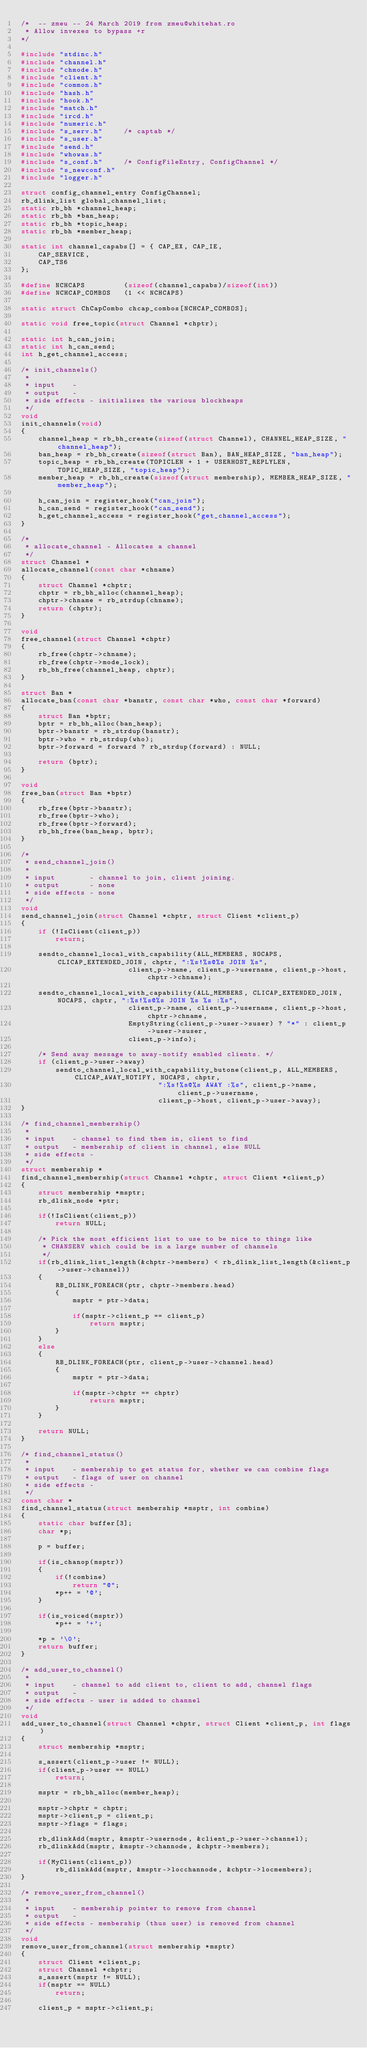<code> <loc_0><loc_0><loc_500><loc_500><_C_>/*  -- zmeu -- 24 March 2019 from zmeu@whitehat.ro
 * Allow invexes to bypass +r
*/

#include "stdinc.h"
#include "channel.h"
#include "chmode.h"
#include "client.h"
#include "common.h"
#include "hash.h"
#include "hook.h"
#include "match.h"
#include "ircd.h"
#include "numeric.h"
#include "s_serv.h"		/* captab */
#include "s_user.h"
#include "send.h"
#include "whowas.h"
#include "s_conf.h"		/* ConfigFileEntry, ConfigChannel */
#include "s_newconf.h"
#include "logger.h"

struct config_channel_entry ConfigChannel;
rb_dlink_list global_channel_list;
static rb_bh *channel_heap;
static rb_bh *ban_heap;
static rb_bh *topic_heap;
static rb_bh *member_heap;

static int channel_capabs[] = { CAP_EX, CAP_IE,
	CAP_SERVICE,
	CAP_TS6
};

#define NCHCAPS         (sizeof(channel_capabs)/sizeof(int))
#define NCHCAP_COMBOS   (1 << NCHCAPS)

static struct ChCapCombo chcap_combos[NCHCAP_COMBOS];

static void free_topic(struct Channel *chptr);

static int h_can_join;
static int h_can_send;
int h_get_channel_access;

/* init_channels()
 *
 * input	-
 * output	-
 * side effects - initialises the various blockheaps
 */
void
init_channels(void)
{
	channel_heap = rb_bh_create(sizeof(struct Channel), CHANNEL_HEAP_SIZE, "channel_heap");
	ban_heap = rb_bh_create(sizeof(struct Ban), BAN_HEAP_SIZE, "ban_heap");
	topic_heap = rb_bh_create(TOPICLEN + 1 + USERHOST_REPLYLEN, TOPIC_HEAP_SIZE, "topic_heap");
	member_heap = rb_bh_create(sizeof(struct membership), MEMBER_HEAP_SIZE, "member_heap");

	h_can_join = register_hook("can_join");
	h_can_send = register_hook("can_send");
	h_get_channel_access = register_hook("get_channel_access");
}

/*
 * allocate_channel - Allocates a channel
 */
struct Channel *
allocate_channel(const char *chname)
{
	struct Channel *chptr;
	chptr = rb_bh_alloc(channel_heap);
	chptr->chname = rb_strdup(chname);
	return (chptr);
}

void
free_channel(struct Channel *chptr)
{
	rb_free(chptr->chname);
	rb_free(chptr->mode_lock);
	rb_bh_free(channel_heap, chptr);
}

struct Ban *
allocate_ban(const char *banstr, const char *who, const char *forward)
{
	struct Ban *bptr;
	bptr = rb_bh_alloc(ban_heap);
	bptr->banstr = rb_strdup(banstr);
	bptr->who = rb_strdup(who);
	bptr->forward = forward ? rb_strdup(forward) : NULL;

	return (bptr);
}

void
free_ban(struct Ban *bptr)
{
	rb_free(bptr->banstr);
	rb_free(bptr->who);
	rb_free(bptr->forward);
	rb_bh_free(ban_heap, bptr);
}

/*
 * send_channel_join()
 *
 * input        - channel to join, client joining.
 * output       - none
 * side effects - none
 */
void
send_channel_join(struct Channel *chptr, struct Client *client_p)
{
	if (!IsClient(client_p))
		return;

	sendto_channel_local_with_capability(ALL_MEMBERS, NOCAPS, CLICAP_EXTENDED_JOIN, chptr, ":%s!%s@%s JOIN %s",
					     client_p->name, client_p->username, client_p->host, chptr->chname);

	sendto_channel_local_with_capability(ALL_MEMBERS, CLICAP_EXTENDED_JOIN, NOCAPS, chptr, ":%s!%s@%s JOIN %s %s :%s",
					     client_p->name, client_p->username, client_p->host, chptr->chname,
					     EmptyString(client_p->user->suser) ? "*" : client_p->user->suser,
					     client_p->info);

	/* Send away message to away-notify enabled clients. */
	if (client_p->user->away)
		sendto_channel_local_with_capability_butone(client_p, ALL_MEMBERS, CLICAP_AWAY_NOTIFY, NOCAPS, chptr,
							    ":%s!%s@%s AWAY :%s", client_p->name, client_p->username,
							    client_p->host, client_p->user->away);
}

/* find_channel_membership()
 *
 * input	- channel to find them in, client to find
 * output	- membership of client in channel, else NULL
 * side effects	-
 */
struct membership *
find_channel_membership(struct Channel *chptr, struct Client *client_p)
{
	struct membership *msptr;
	rb_dlink_node *ptr;

	if(!IsClient(client_p))
		return NULL;

	/* Pick the most efficient list to use to be nice to things like
	 * CHANSERV which could be in a large number of channels
	 */
	if(rb_dlink_list_length(&chptr->members) < rb_dlink_list_length(&client_p->user->channel))
	{
		RB_DLINK_FOREACH(ptr, chptr->members.head)
		{
			msptr = ptr->data;

			if(msptr->client_p == client_p)
				return msptr;
		}
	}
	else
	{
		RB_DLINK_FOREACH(ptr, client_p->user->channel.head)
		{
			msptr = ptr->data;

			if(msptr->chptr == chptr)
				return msptr;
		}
	}

	return NULL;
}

/* find_channel_status()
 *
 * input	- membership to get status for, whether we can combine flags
 * output	- flags of user on channel
 * side effects -
 */
const char *
find_channel_status(struct membership *msptr, int combine)
{
	static char buffer[3];
	char *p;

	p = buffer;

	if(is_chanop(msptr))
	{
		if(!combine)
			return "@";
		*p++ = '@';
	}

	if(is_voiced(msptr))
		*p++ = '+';

	*p = '\0';
	return buffer;
}

/* add_user_to_channel()
 *
 * input	- channel to add client to, client to add, channel flags
 * output	- 
 * side effects - user is added to channel
 */
void
add_user_to_channel(struct Channel *chptr, struct Client *client_p, int flags)
{
	struct membership *msptr;

	s_assert(client_p->user != NULL);
	if(client_p->user == NULL)
		return;

	msptr = rb_bh_alloc(member_heap);

	msptr->chptr = chptr;
	msptr->client_p = client_p;
	msptr->flags = flags;

	rb_dlinkAdd(msptr, &msptr->usernode, &client_p->user->channel);
	rb_dlinkAdd(msptr, &msptr->channode, &chptr->members);

	if(MyClient(client_p))
		rb_dlinkAdd(msptr, &msptr->locchannode, &chptr->locmembers);
}

/* remove_user_from_channel()
 *
 * input	- membership pointer to remove from channel
 * output	-
 * side effects - membership (thus user) is removed from channel
 */
void
remove_user_from_channel(struct membership *msptr)
{
	struct Client *client_p;
	struct Channel *chptr;
	s_assert(msptr != NULL);
	if(msptr == NULL)
		return;

	client_p = msptr->client_p;</code> 